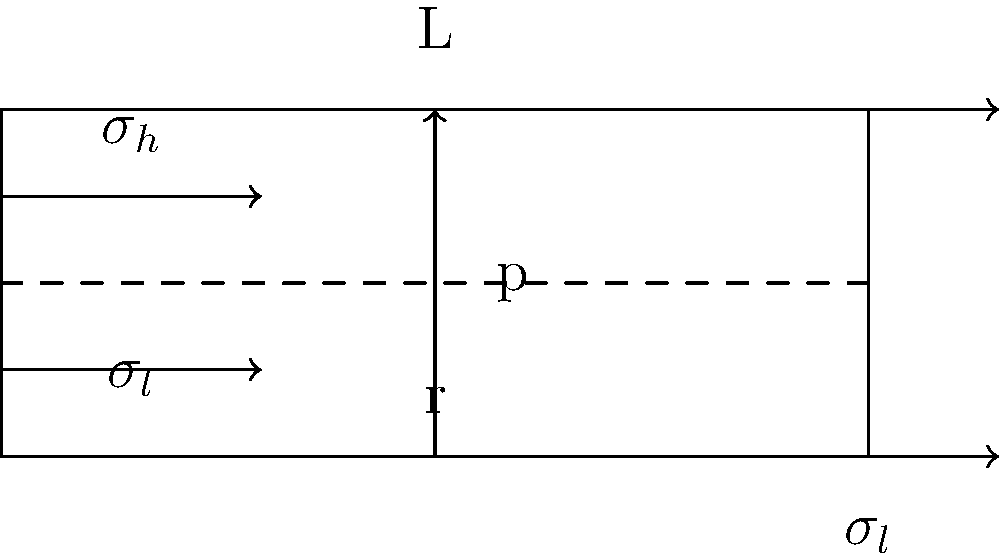In your latest high-tech escape room, you've incorporated a pressurized cylindrical vessel as part of a puzzle. The vessel has a radius $r$ and length $L$, with internal pressure $p$. If the hoop stress $\sigma_h$ is twice the longitudinal stress $\sigma_l$, what is the relationship between the vessel's radius and wall thickness $t$? To solve this problem, let's follow these steps:

1) First, recall the formulas for hoop stress ($\sigma_h$) and longitudinal stress ($\sigma_l$) in a thin-walled pressure vessel:

   $\sigma_h = \frac{pr}{t}$
   $\sigma_l = \frac{pr}{2t}$

2) We're told that the hoop stress is twice the longitudinal stress:

   $\sigma_h = 2\sigma_l$

3) Let's substitute the formulas from step 1 into this equation:

   $\frac{pr}{t} = 2(\frac{pr}{2t})$

4) Simplify the right side:

   $\frac{pr}{t} = \frac{pr}{t}$

5) This equation is always true, regardless of the values of $p$, $r$, and $t$. This means that the relationship between hoop stress and longitudinal stress is a fundamental property of cylindrical pressure vessels.

6) To find the relationship between radius and wall thickness, we need to use the original stress equations. Since we know $\sigma_h = 2\sigma_l$, we can write:

   $\frac{pr}{t} = 2(\frac{pr}{2t})$

7) Simplify:

   $\frac{r}{t} = 2$

8) Therefore, the radius is twice the wall thickness.
Answer: $r = 2t$ 